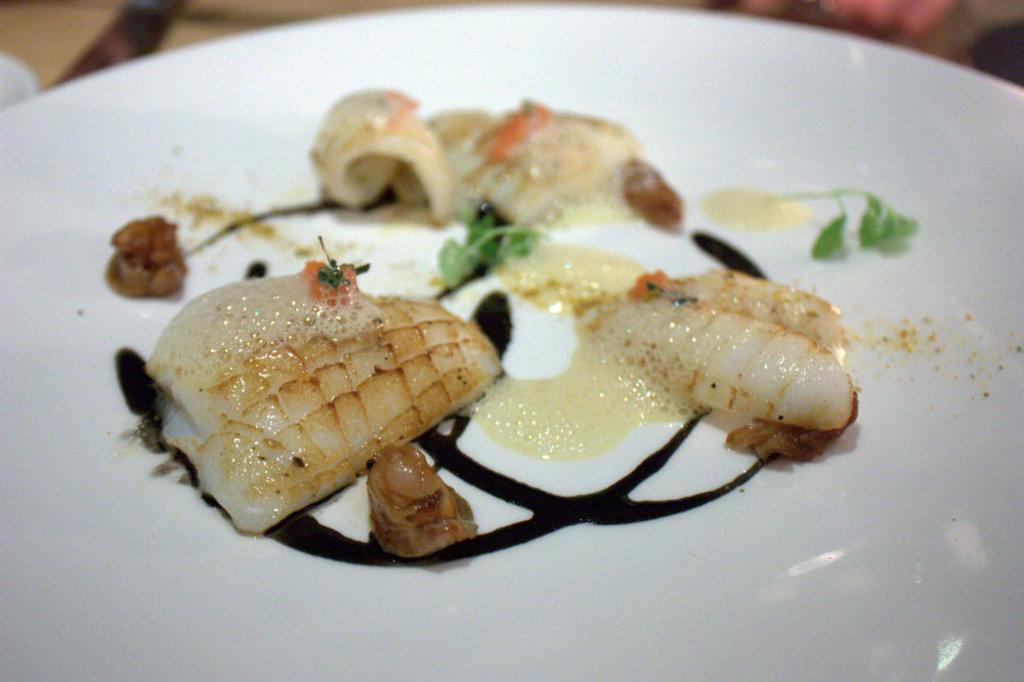What color is the plate that is visible in the image? The plate is white in color. What is on the plate in the image? The plate contains a food item. Is there a bedroom visible in the image? No, there is no bedroom present in the image. Does the food item on the plate have any magical properties? No, there is no indication of any magical properties associated with the food item on the plate. 